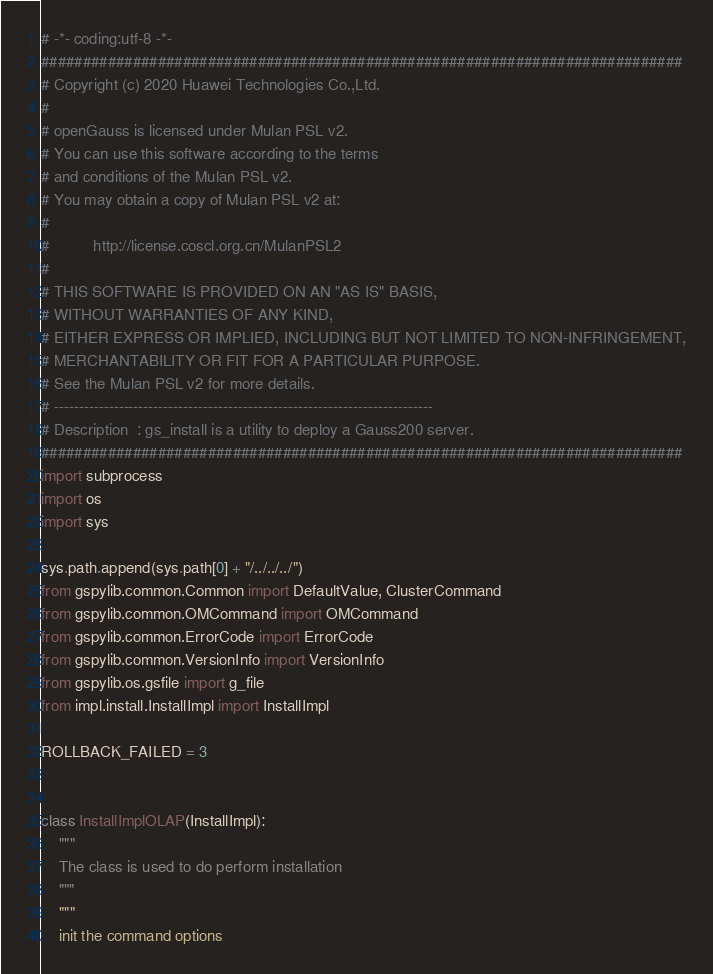Convert code to text. <code><loc_0><loc_0><loc_500><loc_500><_Python_># -*- coding:utf-8 -*-
#############################################################################
# Copyright (c) 2020 Huawei Technologies Co.,Ltd.
#
# openGauss is licensed under Mulan PSL v2.
# You can use this software according to the terms
# and conditions of the Mulan PSL v2.
# You may obtain a copy of Mulan PSL v2 at:
#
#          http://license.coscl.org.cn/MulanPSL2
#
# THIS SOFTWARE IS PROVIDED ON AN "AS IS" BASIS,
# WITHOUT WARRANTIES OF ANY KIND,
# EITHER EXPRESS OR IMPLIED, INCLUDING BUT NOT LIMITED TO NON-INFRINGEMENT,
# MERCHANTABILITY OR FIT FOR A PARTICULAR PURPOSE.
# See the Mulan PSL v2 for more details.
# ----------------------------------------------------------------------------
# Description  : gs_install is a utility to deploy a Gauss200 server.
#############################################################################
import subprocess
import os
import sys

sys.path.append(sys.path[0] + "/../../../")
from gspylib.common.Common import DefaultValue, ClusterCommand
from gspylib.common.OMCommand import OMCommand
from gspylib.common.ErrorCode import ErrorCode
from gspylib.common.VersionInfo import VersionInfo
from gspylib.os.gsfile import g_file
from impl.install.InstallImpl import InstallImpl

ROLLBACK_FAILED = 3


class InstallImplOLAP(InstallImpl):
    """
    The class is used to do perform installation
    """
    """
    init the command options</code> 